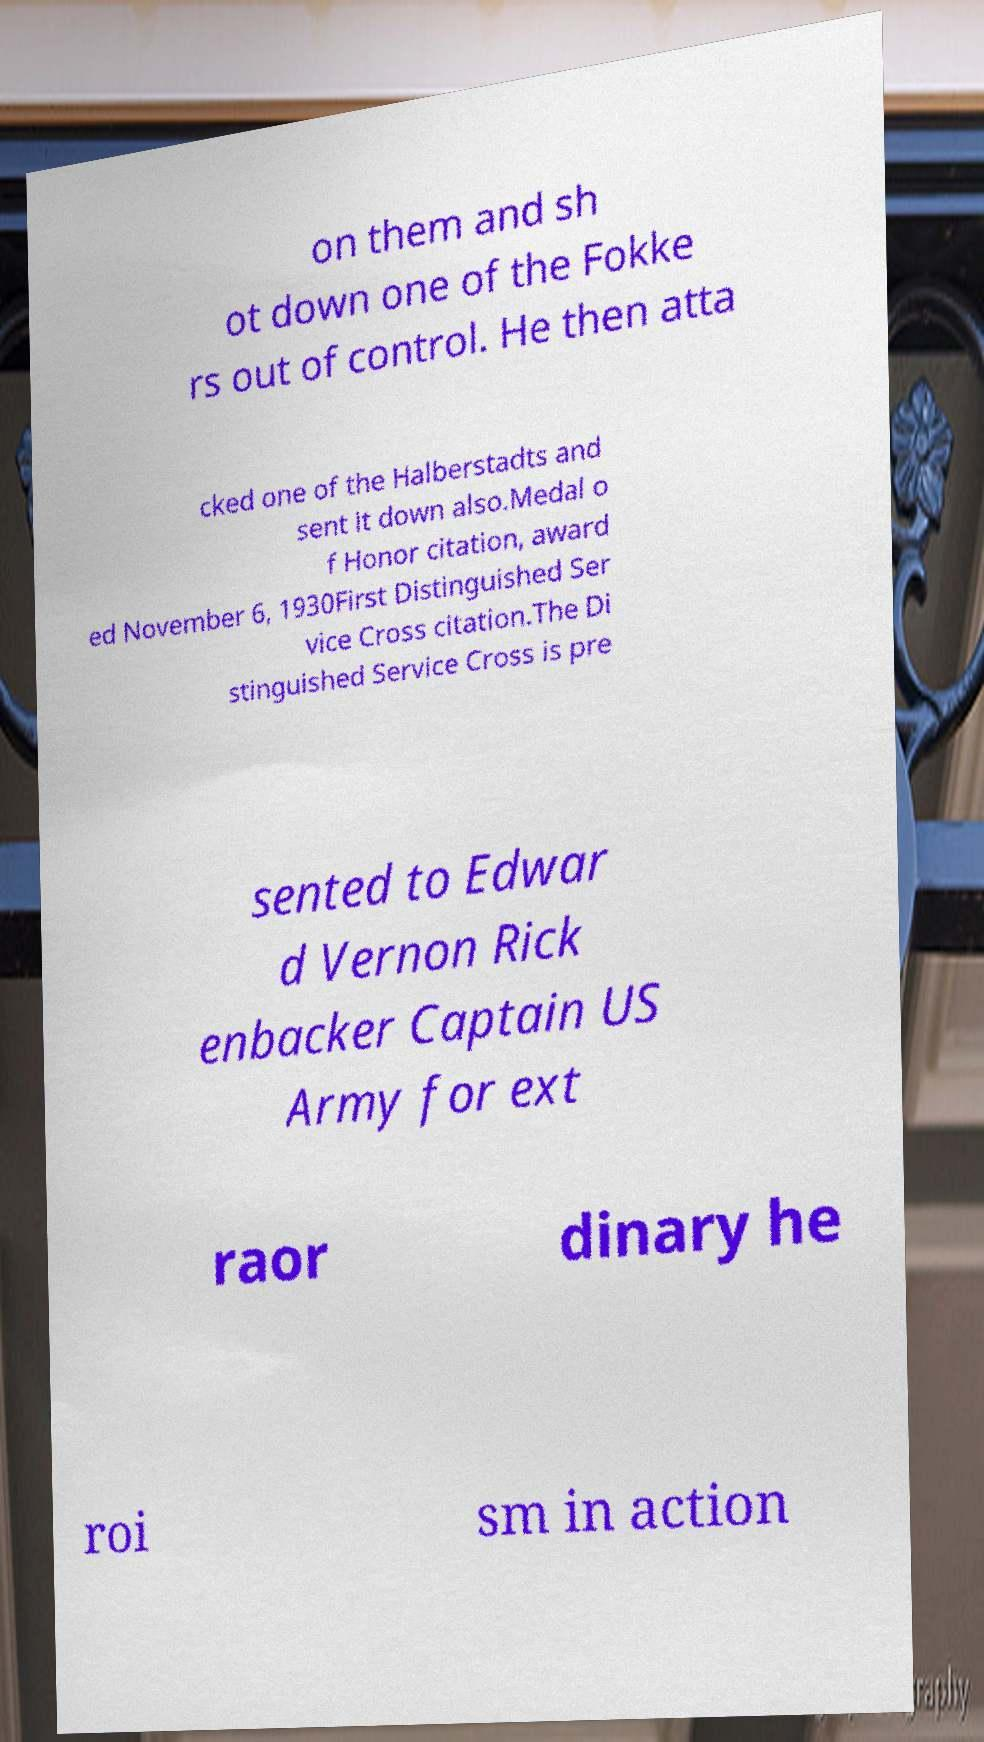Could you assist in decoding the text presented in this image and type it out clearly? on them and sh ot down one of the Fokke rs out of control. He then atta cked one of the Halberstadts and sent it down also.Medal o f Honor citation, award ed November 6, 1930First Distinguished Ser vice Cross citation.The Di stinguished Service Cross is pre sented to Edwar d Vernon Rick enbacker Captain US Army for ext raor dinary he roi sm in action 